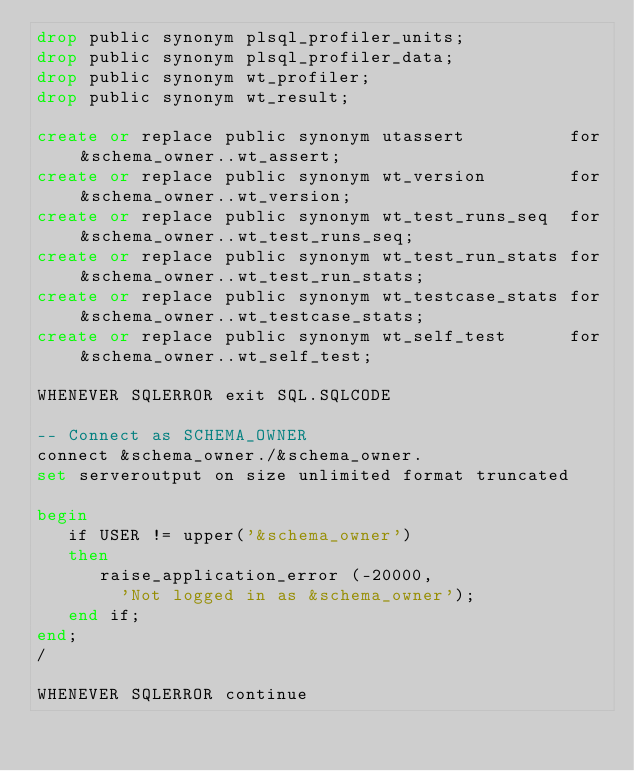Convert code to text. <code><loc_0><loc_0><loc_500><loc_500><_SQL_>drop public synonym plsql_profiler_units;
drop public synonym plsql_profiler_data;
drop public synonym wt_profiler;
drop public synonym wt_result;

create or replace public synonym utassert          for &schema_owner..wt_assert;
create or replace public synonym wt_version        for &schema_owner..wt_version;
create or replace public synonym wt_test_runs_seq  for &schema_owner..wt_test_runs_seq;
create or replace public synonym wt_test_run_stats for &schema_owner..wt_test_run_stats;
create or replace public synonym wt_testcase_stats for &schema_owner..wt_testcase_stats;
create or replace public synonym wt_self_test      for &schema_owner..wt_self_test;

WHENEVER SQLERROR exit SQL.SQLCODE

-- Connect as SCHEMA_OWNER
connect &schema_owner./&schema_owner.
set serveroutput on size unlimited format truncated

begin
   if USER != upper('&schema_owner')
   then
      raise_application_error (-20000,
        'Not logged in as &schema_owner');
   end if;
end;
/

WHENEVER SQLERROR continue
</code> 